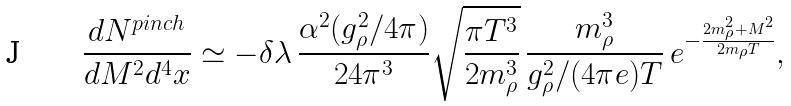<formula> <loc_0><loc_0><loc_500><loc_500>\frac { d N ^ { p i n c h } } { d M ^ { 2 } d ^ { 4 } x } \simeq - \delta \lambda \, \frac { \alpha ^ { 2 } ( g _ { \rho } ^ { 2 } / 4 \pi ) } { 2 4 \pi ^ { 3 } } \sqrt { \frac { \pi T ^ { 3 } } { 2 m _ { \rho } ^ { 3 } } } \, \frac { m _ { \rho } ^ { 3 } } { g _ { \rho } ^ { 2 } / ( 4 \pi e ) T } \, e ^ { - \frac { 2 m _ { \rho } ^ { 2 } + M ^ { 2 } } { 2 m _ { \rho } T } } ,</formula> 